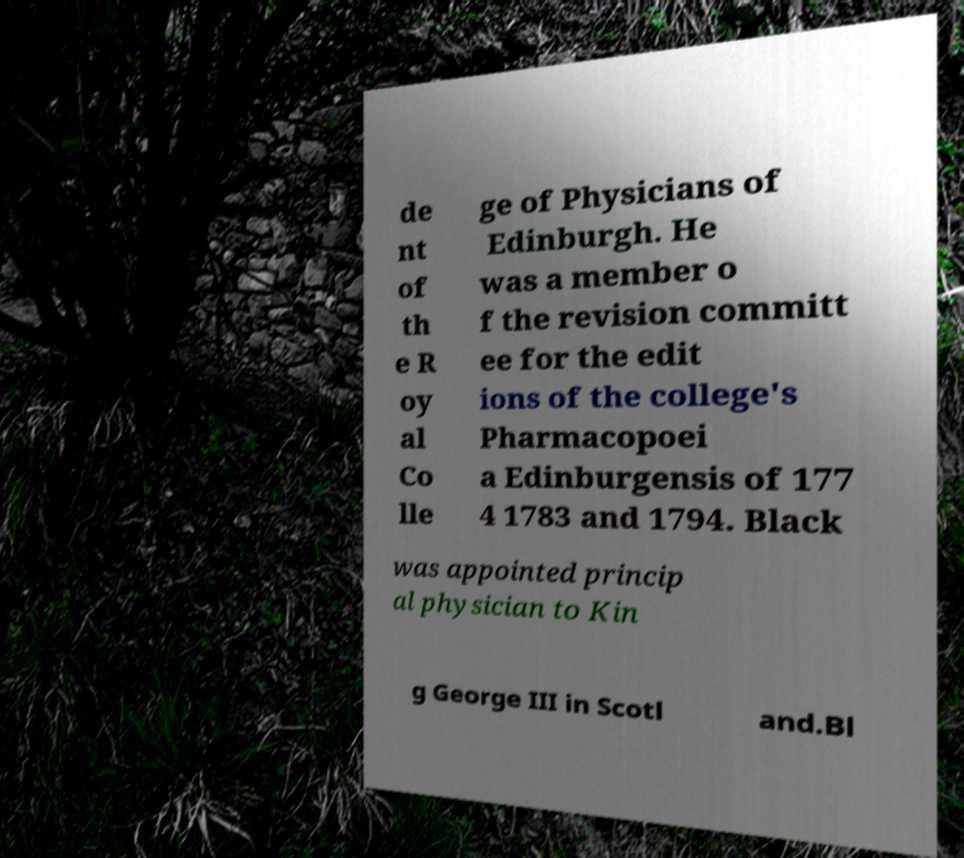I need the written content from this picture converted into text. Can you do that? de nt of th e R oy al Co lle ge of Physicians of Edinburgh. He was a member o f the revision committ ee for the edit ions of the college's Pharmacopoei a Edinburgensis of 177 4 1783 and 1794. Black was appointed princip al physician to Kin g George III in Scotl and.Bl 